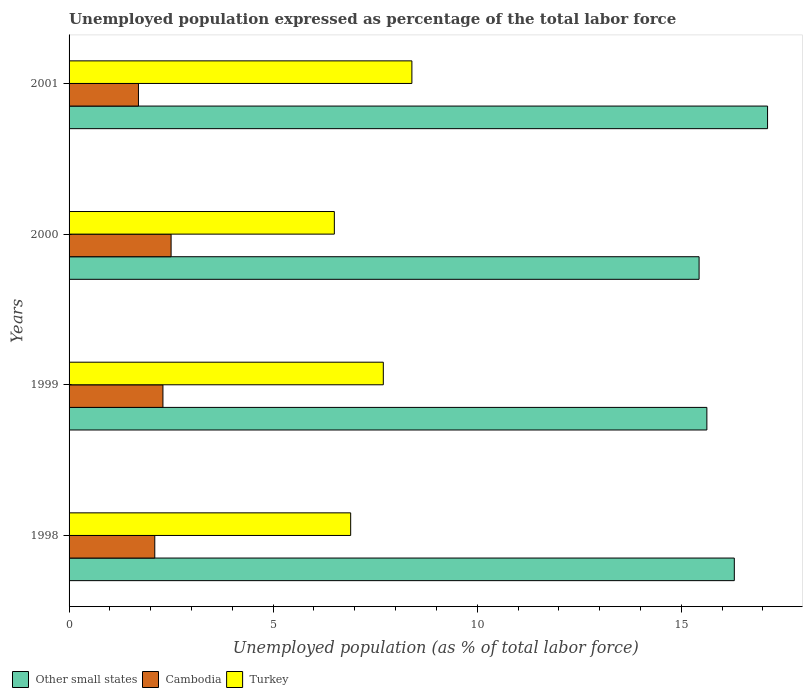How many different coloured bars are there?
Keep it short and to the point. 3. Are the number of bars on each tick of the Y-axis equal?
Offer a very short reply. Yes. How many bars are there on the 2nd tick from the top?
Your answer should be very brief. 3. How many bars are there on the 4th tick from the bottom?
Offer a very short reply. 3. In how many cases, is the number of bars for a given year not equal to the number of legend labels?
Offer a terse response. 0. What is the unemployment in in Turkey in 2001?
Give a very brief answer. 8.4. Across all years, what is the maximum unemployment in in Other small states?
Offer a terse response. 17.12. Across all years, what is the minimum unemployment in in Cambodia?
Your answer should be compact. 1.7. In which year was the unemployment in in Turkey maximum?
Ensure brevity in your answer.  2001. In which year was the unemployment in in Turkey minimum?
Give a very brief answer. 2000. What is the total unemployment in in Other small states in the graph?
Your response must be concise. 64.48. What is the difference between the unemployment in in Cambodia in 2000 and that in 2001?
Your response must be concise. 0.8. What is the difference between the unemployment in in Turkey in 1998 and the unemployment in in Cambodia in 2001?
Make the answer very short. 5.2. What is the average unemployment in in Other small states per year?
Your answer should be very brief. 16.12. In the year 1999, what is the difference between the unemployment in in Turkey and unemployment in in Other small states?
Your response must be concise. -7.93. In how many years, is the unemployment in in Turkey greater than 16 %?
Your answer should be very brief. 0. What is the ratio of the unemployment in in Cambodia in 1999 to that in 2001?
Offer a very short reply. 1.35. Is the difference between the unemployment in in Turkey in 1998 and 1999 greater than the difference between the unemployment in in Other small states in 1998 and 1999?
Keep it short and to the point. No. What is the difference between the highest and the second highest unemployment in in Other small states?
Your answer should be compact. 0.81. What is the difference between the highest and the lowest unemployment in in Turkey?
Provide a succinct answer. 1.9. In how many years, is the unemployment in in Cambodia greater than the average unemployment in in Cambodia taken over all years?
Your response must be concise. 2. Is the sum of the unemployment in in Turkey in 1998 and 2001 greater than the maximum unemployment in in Other small states across all years?
Your response must be concise. No. What does the 2nd bar from the top in 1999 represents?
Your response must be concise. Cambodia. What does the 1st bar from the bottom in 1998 represents?
Your answer should be very brief. Other small states. Is it the case that in every year, the sum of the unemployment in in Cambodia and unemployment in in Other small states is greater than the unemployment in in Turkey?
Make the answer very short. Yes. How many years are there in the graph?
Provide a short and direct response. 4. What is the difference between two consecutive major ticks on the X-axis?
Provide a succinct answer. 5. Are the values on the major ticks of X-axis written in scientific E-notation?
Your answer should be very brief. No. Does the graph contain any zero values?
Offer a very short reply. No. Where does the legend appear in the graph?
Give a very brief answer. Bottom left. How are the legend labels stacked?
Your response must be concise. Horizontal. What is the title of the graph?
Provide a short and direct response. Unemployed population expressed as percentage of the total labor force. Does "Greece" appear as one of the legend labels in the graph?
Keep it short and to the point. No. What is the label or title of the X-axis?
Your answer should be compact. Unemployed population (as % of total labor force). What is the label or title of the Y-axis?
Your response must be concise. Years. What is the Unemployed population (as % of total labor force) of Other small states in 1998?
Keep it short and to the point. 16.3. What is the Unemployed population (as % of total labor force) of Cambodia in 1998?
Provide a succinct answer. 2.1. What is the Unemployed population (as % of total labor force) of Turkey in 1998?
Provide a succinct answer. 6.9. What is the Unemployed population (as % of total labor force) in Other small states in 1999?
Ensure brevity in your answer.  15.63. What is the Unemployed population (as % of total labor force) in Cambodia in 1999?
Your response must be concise. 2.3. What is the Unemployed population (as % of total labor force) of Turkey in 1999?
Your response must be concise. 7.7. What is the Unemployed population (as % of total labor force) in Other small states in 2000?
Give a very brief answer. 15.44. What is the Unemployed population (as % of total labor force) of Other small states in 2001?
Provide a short and direct response. 17.12. What is the Unemployed population (as % of total labor force) of Cambodia in 2001?
Provide a short and direct response. 1.7. What is the Unemployed population (as % of total labor force) in Turkey in 2001?
Give a very brief answer. 8.4. Across all years, what is the maximum Unemployed population (as % of total labor force) of Other small states?
Your response must be concise. 17.12. Across all years, what is the maximum Unemployed population (as % of total labor force) in Turkey?
Make the answer very short. 8.4. Across all years, what is the minimum Unemployed population (as % of total labor force) in Other small states?
Ensure brevity in your answer.  15.44. Across all years, what is the minimum Unemployed population (as % of total labor force) of Cambodia?
Provide a succinct answer. 1.7. What is the total Unemployed population (as % of total labor force) of Other small states in the graph?
Your answer should be compact. 64.48. What is the total Unemployed population (as % of total labor force) in Cambodia in the graph?
Give a very brief answer. 8.6. What is the total Unemployed population (as % of total labor force) in Turkey in the graph?
Offer a very short reply. 29.5. What is the difference between the Unemployed population (as % of total labor force) in Other small states in 1998 and that in 1999?
Your response must be concise. 0.67. What is the difference between the Unemployed population (as % of total labor force) in Other small states in 1998 and that in 2000?
Your response must be concise. 0.86. What is the difference between the Unemployed population (as % of total labor force) of Other small states in 1998 and that in 2001?
Make the answer very short. -0.81. What is the difference between the Unemployed population (as % of total labor force) in Cambodia in 1998 and that in 2001?
Ensure brevity in your answer.  0.4. What is the difference between the Unemployed population (as % of total labor force) of Turkey in 1998 and that in 2001?
Ensure brevity in your answer.  -1.5. What is the difference between the Unemployed population (as % of total labor force) of Other small states in 1999 and that in 2000?
Provide a succinct answer. 0.19. What is the difference between the Unemployed population (as % of total labor force) in Cambodia in 1999 and that in 2000?
Provide a succinct answer. -0.2. What is the difference between the Unemployed population (as % of total labor force) of Turkey in 1999 and that in 2000?
Provide a succinct answer. 1.2. What is the difference between the Unemployed population (as % of total labor force) of Other small states in 1999 and that in 2001?
Provide a succinct answer. -1.49. What is the difference between the Unemployed population (as % of total labor force) of Other small states in 2000 and that in 2001?
Give a very brief answer. -1.68. What is the difference between the Unemployed population (as % of total labor force) in Other small states in 1998 and the Unemployed population (as % of total labor force) in Cambodia in 1999?
Give a very brief answer. 14. What is the difference between the Unemployed population (as % of total labor force) of Other small states in 1998 and the Unemployed population (as % of total labor force) of Turkey in 1999?
Your answer should be compact. 8.6. What is the difference between the Unemployed population (as % of total labor force) of Other small states in 1998 and the Unemployed population (as % of total labor force) of Cambodia in 2000?
Offer a terse response. 13.8. What is the difference between the Unemployed population (as % of total labor force) of Other small states in 1998 and the Unemployed population (as % of total labor force) of Turkey in 2000?
Provide a short and direct response. 9.8. What is the difference between the Unemployed population (as % of total labor force) of Cambodia in 1998 and the Unemployed population (as % of total labor force) of Turkey in 2000?
Offer a very short reply. -4.4. What is the difference between the Unemployed population (as % of total labor force) of Other small states in 1998 and the Unemployed population (as % of total labor force) of Cambodia in 2001?
Your response must be concise. 14.6. What is the difference between the Unemployed population (as % of total labor force) in Other small states in 1998 and the Unemployed population (as % of total labor force) in Turkey in 2001?
Make the answer very short. 7.9. What is the difference between the Unemployed population (as % of total labor force) in Other small states in 1999 and the Unemployed population (as % of total labor force) in Cambodia in 2000?
Provide a succinct answer. 13.13. What is the difference between the Unemployed population (as % of total labor force) in Other small states in 1999 and the Unemployed population (as % of total labor force) in Turkey in 2000?
Keep it short and to the point. 9.13. What is the difference between the Unemployed population (as % of total labor force) in Other small states in 1999 and the Unemployed population (as % of total labor force) in Cambodia in 2001?
Offer a terse response. 13.93. What is the difference between the Unemployed population (as % of total labor force) in Other small states in 1999 and the Unemployed population (as % of total labor force) in Turkey in 2001?
Keep it short and to the point. 7.23. What is the difference between the Unemployed population (as % of total labor force) of Other small states in 2000 and the Unemployed population (as % of total labor force) of Cambodia in 2001?
Provide a short and direct response. 13.74. What is the difference between the Unemployed population (as % of total labor force) in Other small states in 2000 and the Unemployed population (as % of total labor force) in Turkey in 2001?
Provide a short and direct response. 7.04. What is the average Unemployed population (as % of total labor force) in Other small states per year?
Provide a short and direct response. 16.12. What is the average Unemployed population (as % of total labor force) of Cambodia per year?
Provide a succinct answer. 2.15. What is the average Unemployed population (as % of total labor force) in Turkey per year?
Provide a short and direct response. 7.38. In the year 1998, what is the difference between the Unemployed population (as % of total labor force) in Other small states and Unemployed population (as % of total labor force) in Cambodia?
Give a very brief answer. 14.2. In the year 1998, what is the difference between the Unemployed population (as % of total labor force) in Other small states and Unemployed population (as % of total labor force) in Turkey?
Ensure brevity in your answer.  9.4. In the year 1999, what is the difference between the Unemployed population (as % of total labor force) of Other small states and Unemployed population (as % of total labor force) of Cambodia?
Give a very brief answer. 13.33. In the year 1999, what is the difference between the Unemployed population (as % of total labor force) of Other small states and Unemployed population (as % of total labor force) of Turkey?
Your answer should be compact. 7.93. In the year 1999, what is the difference between the Unemployed population (as % of total labor force) in Cambodia and Unemployed population (as % of total labor force) in Turkey?
Your answer should be very brief. -5.4. In the year 2000, what is the difference between the Unemployed population (as % of total labor force) in Other small states and Unemployed population (as % of total labor force) in Cambodia?
Your response must be concise. 12.94. In the year 2000, what is the difference between the Unemployed population (as % of total labor force) in Other small states and Unemployed population (as % of total labor force) in Turkey?
Your response must be concise. 8.94. In the year 2001, what is the difference between the Unemployed population (as % of total labor force) in Other small states and Unemployed population (as % of total labor force) in Cambodia?
Offer a very short reply. 15.42. In the year 2001, what is the difference between the Unemployed population (as % of total labor force) of Other small states and Unemployed population (as % of total labor force) of Turkey?
Provide a succinct answer. 8.72. What is the ratio of the Unemployed population (as % of total labor force) in Other small states in 1998 to that in 1999?
Your answer should be compact. 1.04. What is the ratio of the Unemployed population (as % of total labor force) in Cambodia in 1998 to that in 1999?
Provide a succinct answer. 0.91. What is the ratio of the Unemployed population (as % of total labor force) in Turkey in 1998 to that in 1999?
Your response must be concise. 0.9. What is the ratio of the Unemployed population (as % of total labor force) of Other small states in 1998 to that in 2000?
Offer a very short reply. 1.06. What is the ratio of the Unemployed population (as % of total labor force) of Cambodia in 1998 to that in 2000?
Provide a succinct answer. 0.84. What is the ratio of the Unemployed population (as % of total labor force) of Turkey in 1998 to that in 2000?
Offer a very short reply. 1.06. What is the ratio of the Unemployed population (as % of total labor force) of Other small states in 1998 to that in 2001?
Offer a very short reply. 0.95. What is the ratio of the Unemployed population (as % of total labor force) of Cambodia in 1998 to that in 2001?
Provide a succinct answer. 1.24. What is the ratio of the Unemployed population (as % of total labor force) of Turkey in 1998 to that in 2001?
Your response must be concise. 0.82. What is the ratio of the Unemployed population (as % of total labor force) in Other small states in 1999 to that in 2000?
Make the answer very short. 1.01. What is the ratio of the Unemployed population (as % of total labor force) in Turkey in 1999 to that in 2000?
Make the answer very short. 1.18. What is the ratio of the Unemployed population (as % of total labor force) in Other small states in 1999 to that in 2001?
Your answer should be compact. 0.91. What is the ratio of the Unemployed population (as % of total labor force) in Cambodia in 1999 to that in 2001?
Make the answer very short. 1.35. What is the ratio of the Unemployed population (as % of total labor force) of Turkey in 1999 to that in 2001?
Offer a terse response. 0.92. What is the ratio of the Unemployed population (as % of total labor force) of Other small states in 2000 to that in 2001?
Offer a very short reply. 0.9. What is the ratio of the Unemployed population (as % of total labor force) in Cambodia in 2000 to that in 2001?
Ensure brevity in your answer.  1.47. What is the ratio of the Unemployed population (as % of total labor force) in Turkey in 2000 to that in 2001?
Offer a terse response. 0.77. What is the difference between the highest and the second highest Unemployed population (as % of total labor force) in Other small states?
Make the answer very short. 0.81. What is the difference between the highest and the second highest Unemployed population (as % of total labor force) in Turkey?
Keep it short and to the point. 0.7. What is the difference between the highest and the lowest Unemployed population (as % of total labor force) in Other small states?
Your answer should be compact. 1.68. What is the difference between the highest and the lowest Unemployed population (as % of total labor force) in Turkey?
Keep it short and to the point. 1.9. 